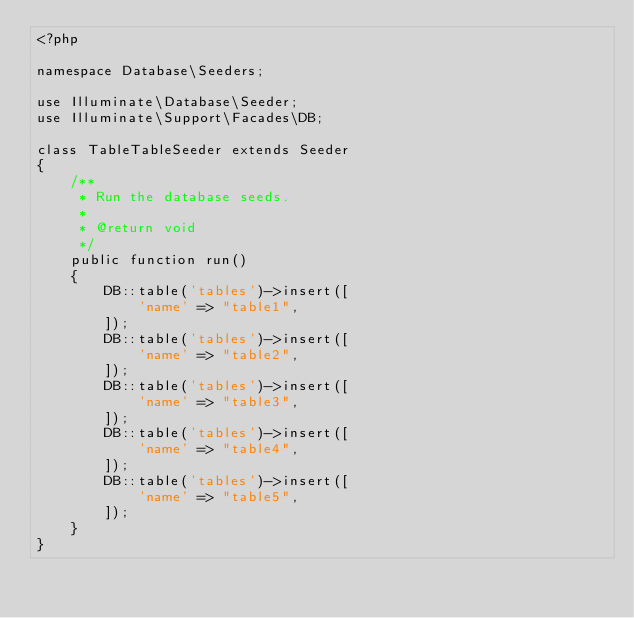<code> <loc_0><loc_0><loc_500><loc_500><_PHP_><?php

namespace Database\Seeders;

use Illuminate\Database\Seeder;
use Illuminate\Support\Facades\DB;

class TableTableSeeder extends Seeder
{
    /**
     * Run the database seeds.
     *
     * @return void
     */
    public function run()
    {
        DB::table('tables')->insert([
            'name' => "table1",
        ]);
        DB::table('tables')->insert([
            'name' => "table2",
        ]);
        DB::table('tables')->insert([
            'name' => "table3",
        ]);
        DB::table('tables')->insert([
            'name' => "table4",
        ]);
        DB::table('tables')->insert([
            'name' => "table5",
        ]);
    }
}
</code> 